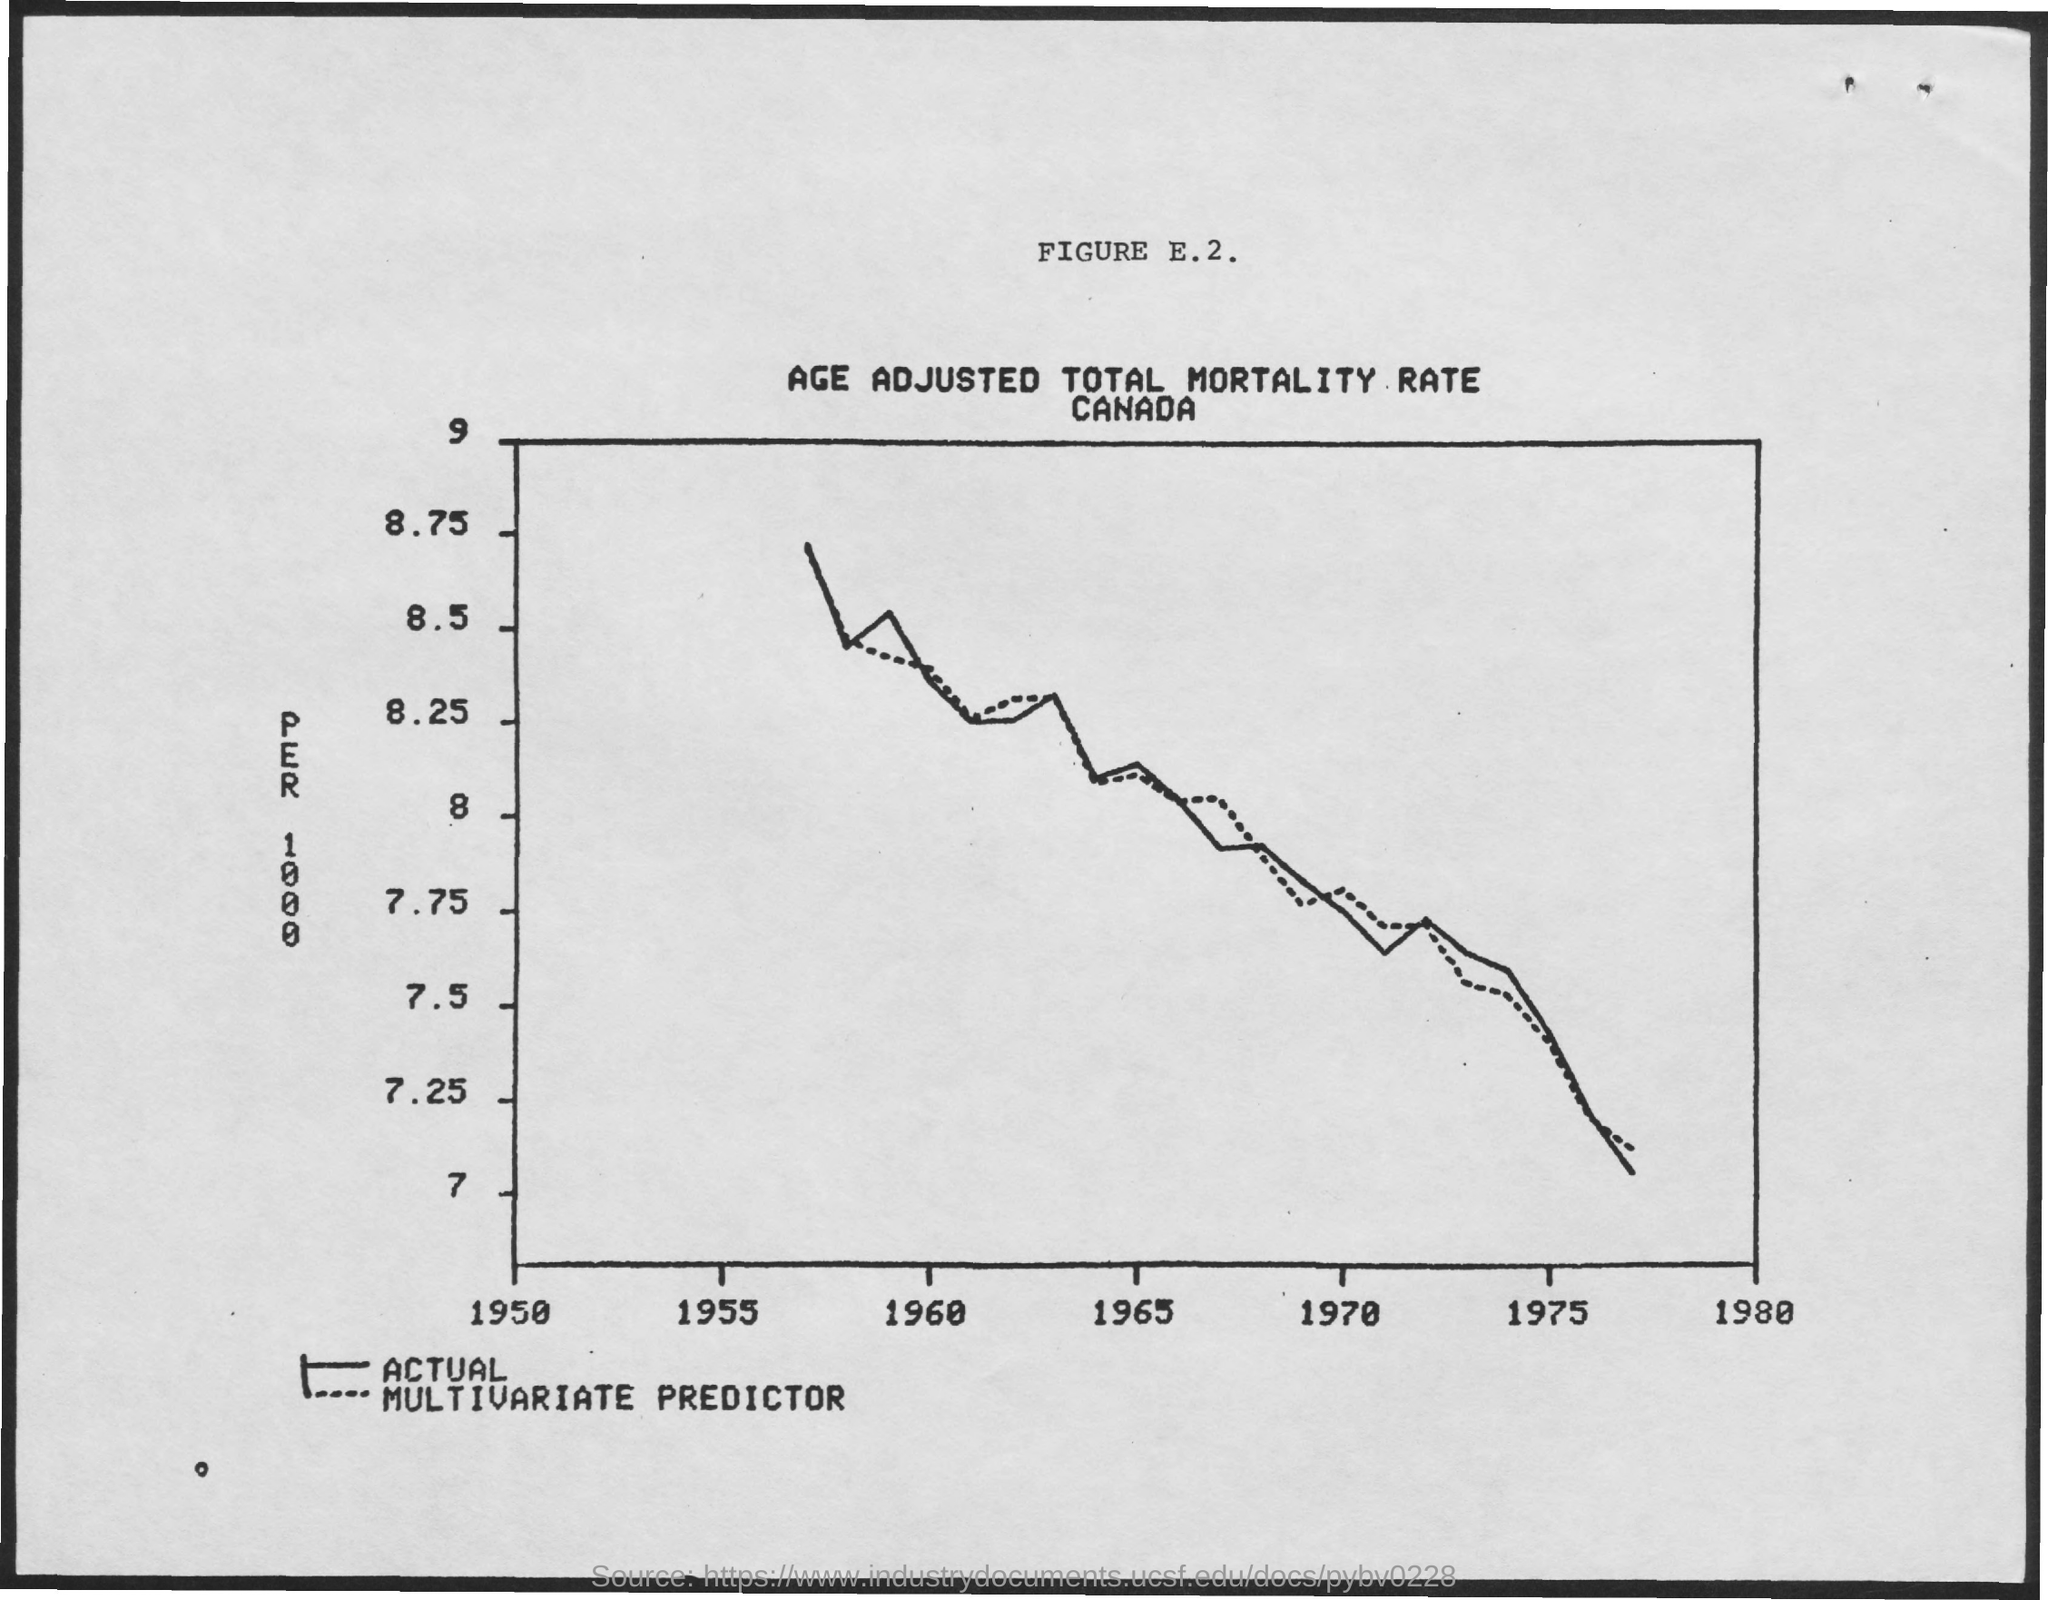Mention a couple of crucial points in this snapshot. The title of Figure E.2 is "Age-Adjusted Total Mortality Rate Canada", which provides a comparative analysis of mortality rates in Canada over time, adjusted for age. 